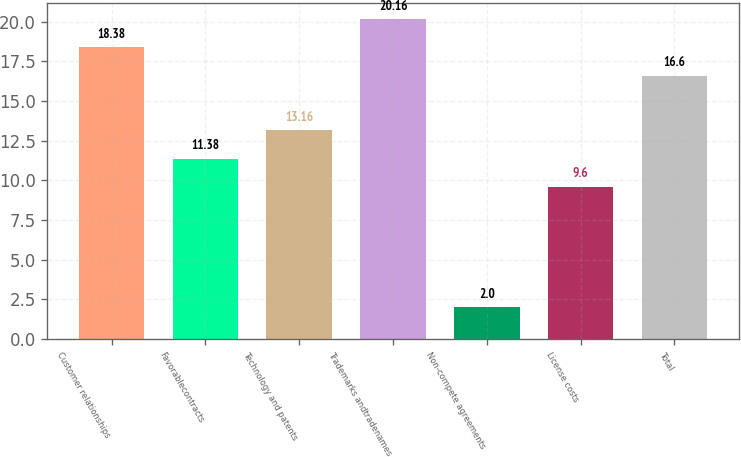Convert chart. <chart><loc_0><loc_0><loc_500><loc_500><bar_chart><fcel>Customer relationships<fcel>Favorablecontracts<fcel>Technology and patents<fcel>Trademarks andtradenames<fcel>Non-compete agreements<fcel>License costs<fcel>Total<nl><fcel>18.38<fcel>11.38<fcel>13.16<fcel>20.16<fcel>2<fcel>9.6<fcel>16.6<nl></chart> 